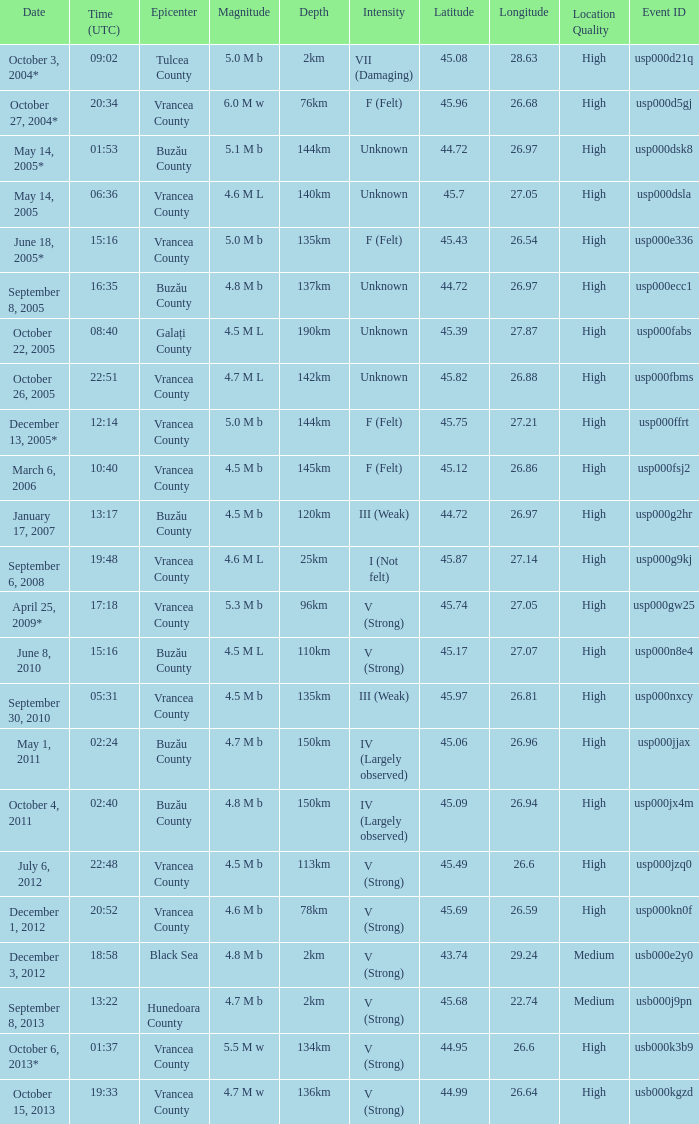What is the magnitude with epicenter at Vrancea County, unknown intensity and which happened at 06:36? 4.6 M L. 